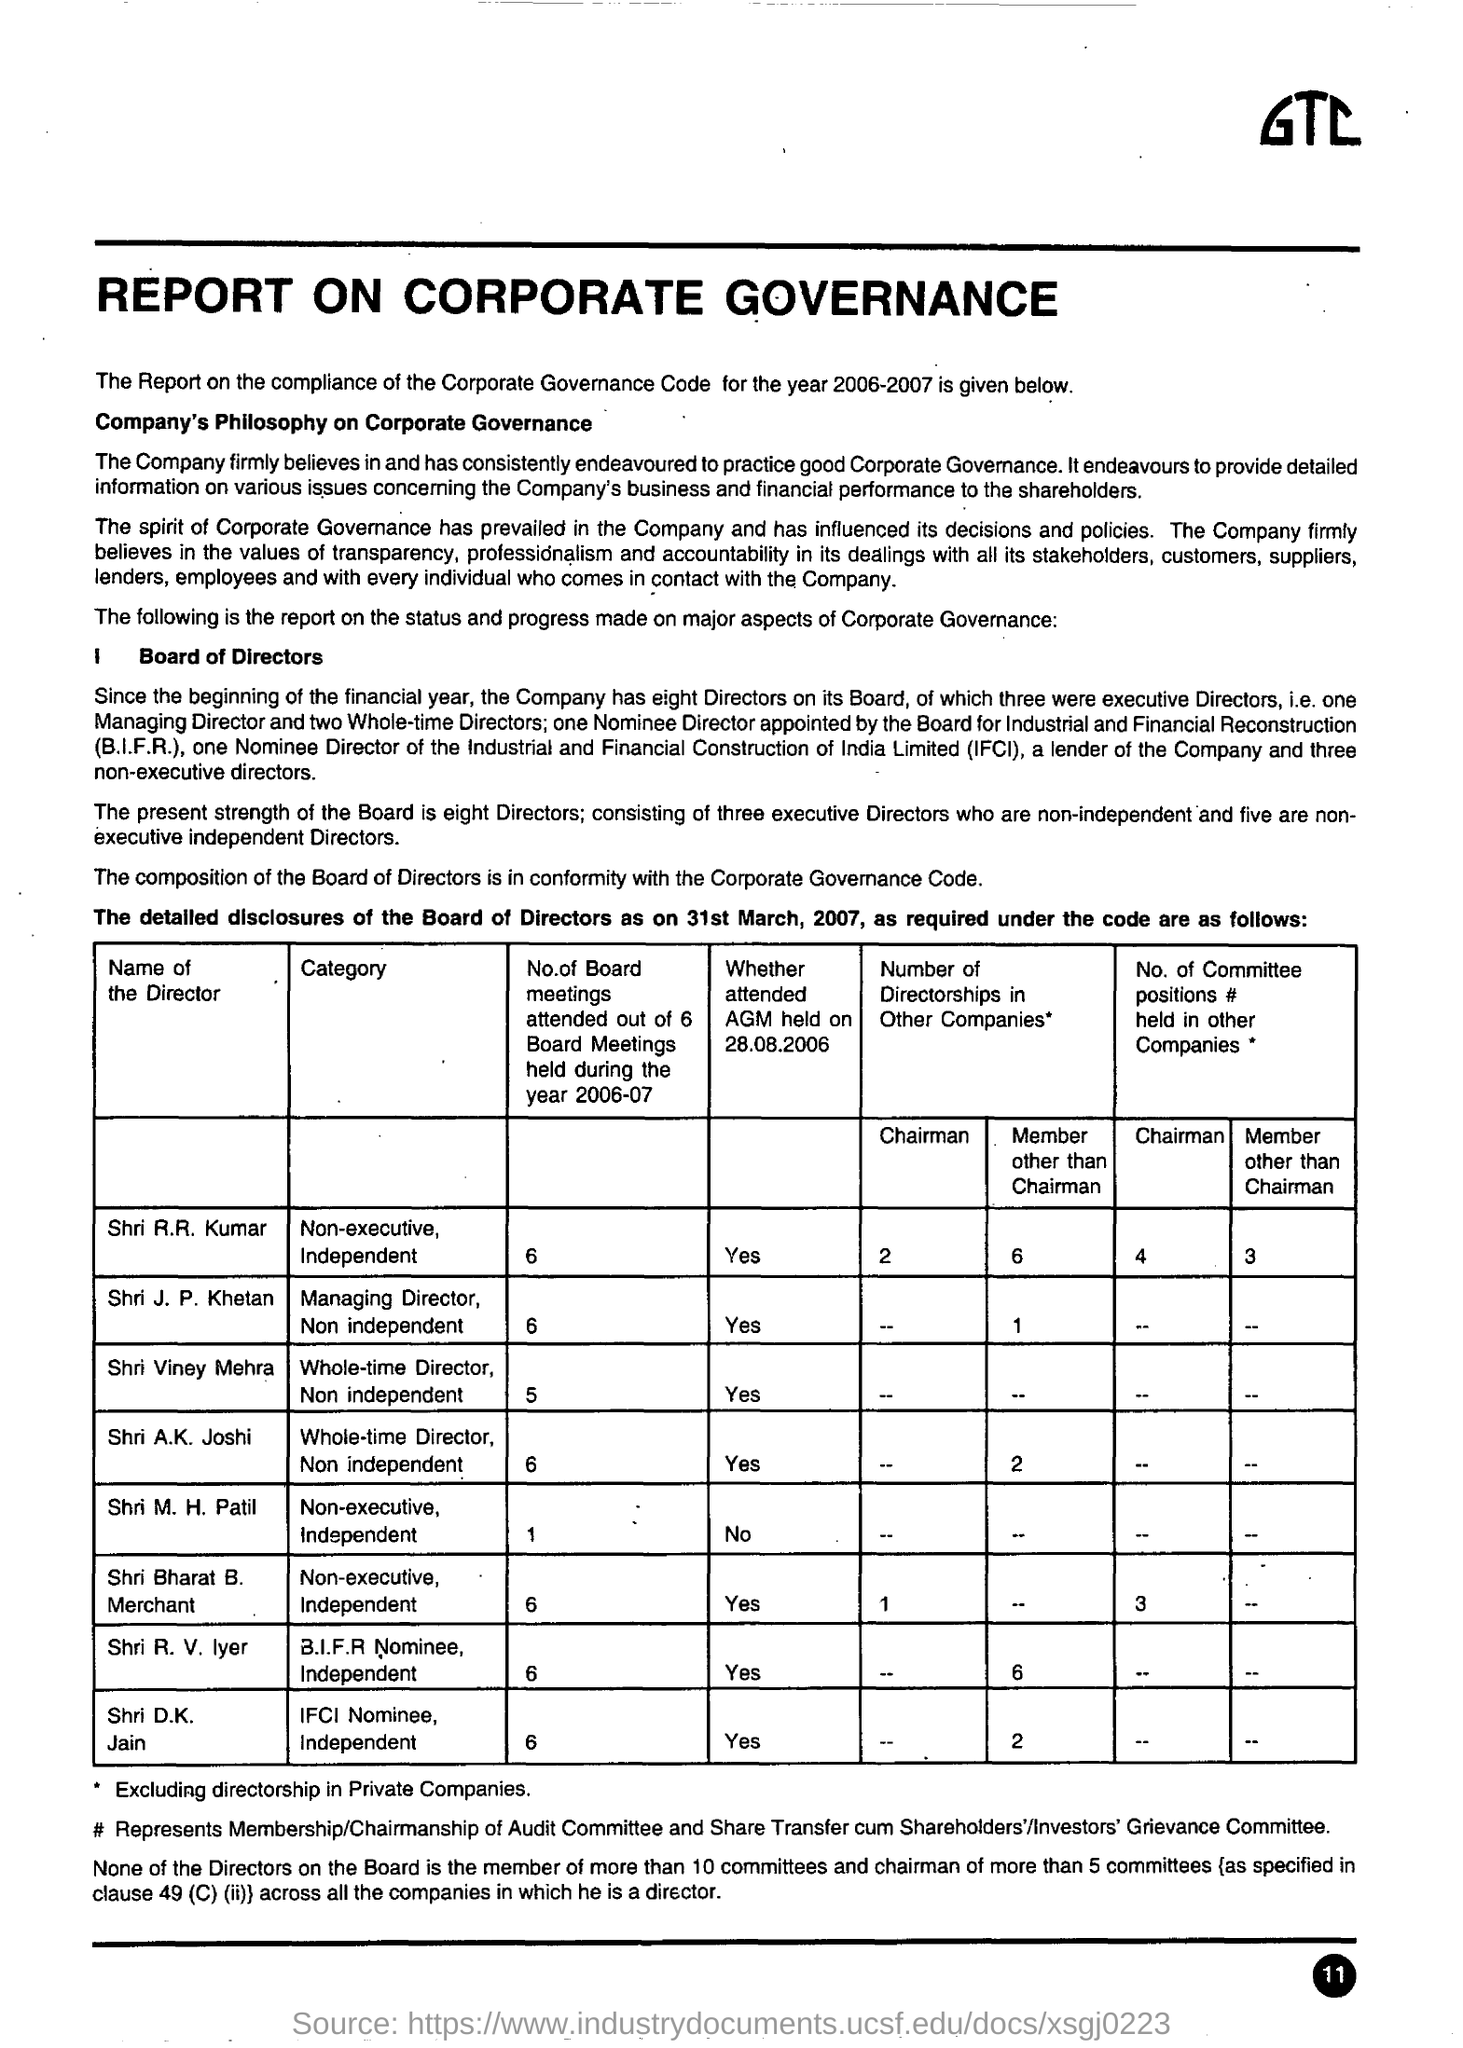List a handful of essential elements in this visual. There are eight directors on the Company Board. The report on the compliance of the corporate governance code was given in the year 2006-2007. The number of Board meetings attended by Shri M.H. Patil during the year 2006-07 was 1. There are five non-executive independent directors on the board. IFCI stands for Industrial and Financial Construction of India Limited, which is a public sector undertaking engaged in the business of financing and promoting industrial growth in India. 